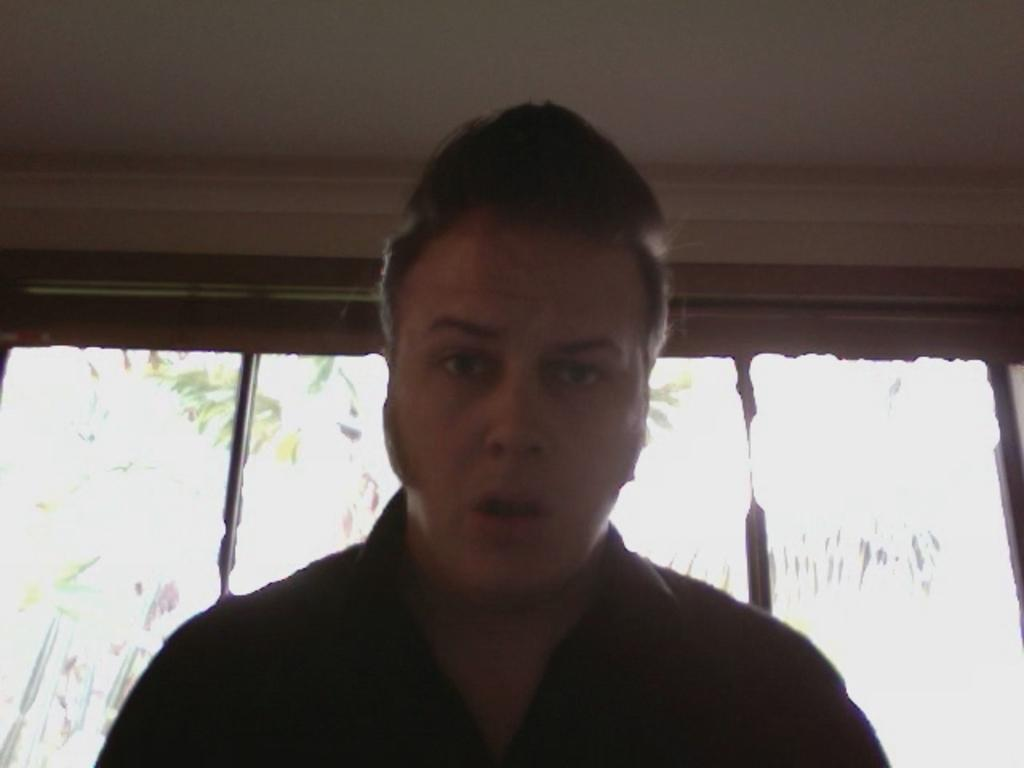Who is present in the image? There is a man in the image. What can be seen in the background of the image? There are green color leaves and white color visible in the background of the image. What type of chair is the dad sitting on in the image? There is no dad or chair present in the image; it only features a man and the background. 